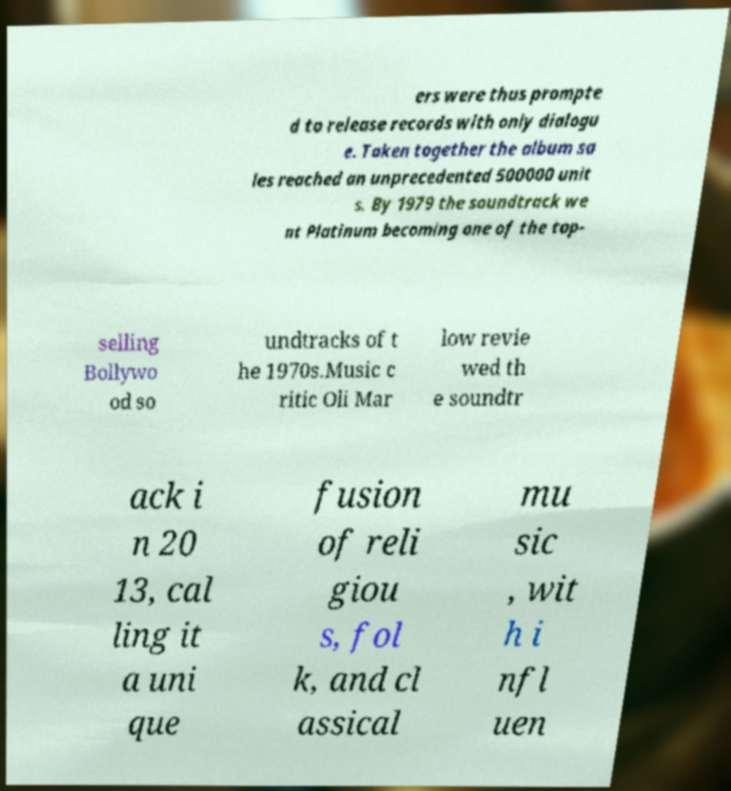Could you extract and type out the text from this image? ers were thus prompte d to release records with only dialogu e. Taken together the album sa les reached an unprecedented 500000 unit s. By 1979 the soundtrack we nt Platinum becoming one of the top- selling Bollywo od so undtracks of t he 1970s.Music c ritic Oli Mar low revie wed th e soundtr ack i n 20 13, cal ling it a uni que fusion of reli giou s, fol k, and cl assical mu sic , wit h i nfl uen 